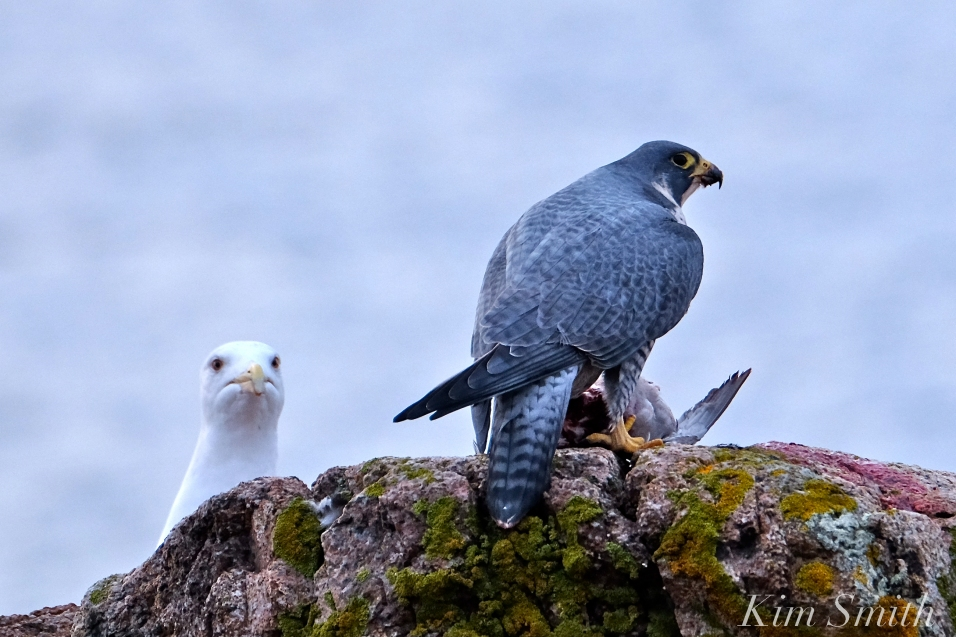What might be the interactions between the Peregrine Falcon and the gull in the image? In this scenario, the Peregrine Falcon is likely the dominant bird, having just captured its prey and is now guarding it. The presence of the gull could indicate several types of interactions. The gull might be waiting for an opportunity to scavenge any leftovers once the falcon has finished its meal. Alternatively, the gull could be assessing whether it can intimidate the falcon into abandoning its catch. Peregrine Falcons are powerful and agile predators, so the gull is likely cautious and maintains a respectful distance, understanding that challenging the falcon could be risky. Could the gull possibly be a threat to the falcon’s catch? While it’s unlikely that the gull poses a direct physical threat to the Peregrine Falcon due to the falcon's superior hunting skills and strength, the gull might still pose a threat to the falcon’s catch. Gulls are opportunistic feeders and might try to steal or scavenge food when the hunter is momentarily distracted. However, given the falcon's alert and defensive posture, it is prepared to fend off such attempts and protect its meal. 